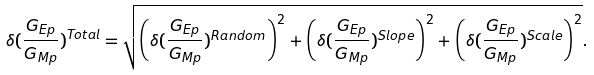<formula> <loc_0><loc_0><loc_500><loc_500>\delta ( \frac { G _ { E p } } { G _ { M p } } ) ^ { T o t a l } = \sqrt { \left ( \delta ( \frac { G _ { E p } } { G _ { M p } } ) ^ { R a n d o m } \right ) ^ { 2 } + \left ( \delta ( \frac { G _ { E p } } { G _ { M p } } ) ^ { S l o p e } \right ) ^ { 2 } + \left ( \delta ( \frac { G _ { E p } } { G _ { M p } } ) ^ { S c a l e } \right ) ^ { 2 } } .</formula> 